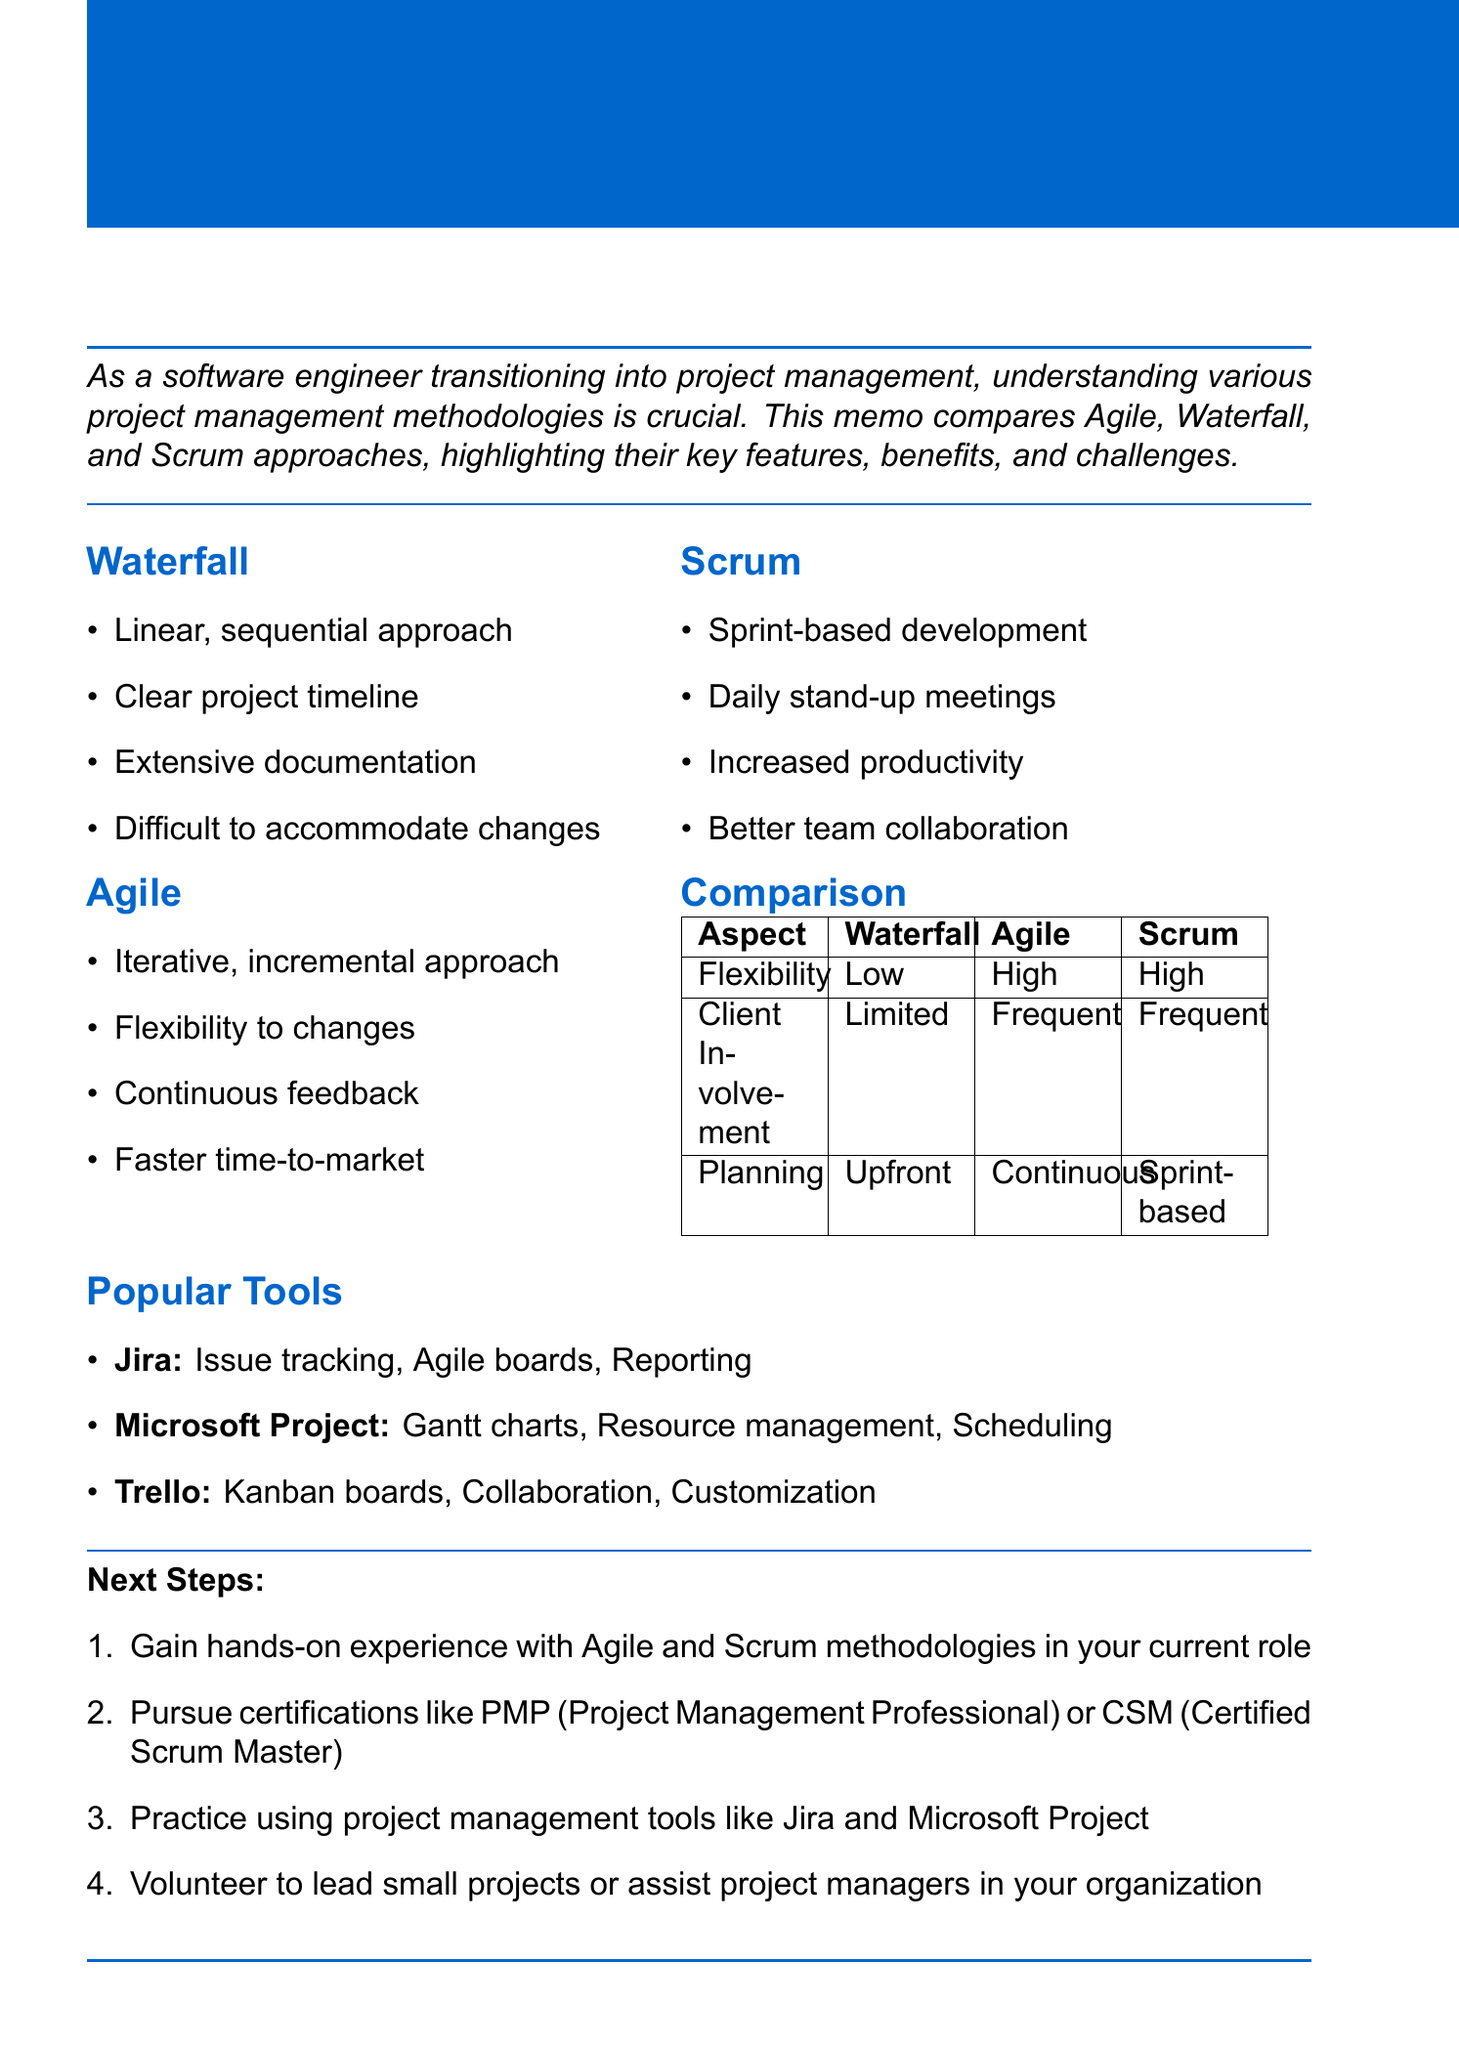What is the title of the memo? The title is provided at the beginning of the document, summarizing the content.
Answer: Project Management Methodologies Comparison: Agile vs. Waterfall vs. Scrum What methodology is described as "a linear, sequential approach"? This description is located in the section discussing different methodologies.
Answer: Waterfall Which methodology is characterized by "sprint-based development"? This characteristic is mentioned in the section focused on Scrum.
Answer: Scrum What are the two methodologies that allow for frequent client involvement? This information is retrieved from the comparison aspects related to client involvement.
Answer: Agile, Scrum What is one major challenge associated with Waterfall? The challenges are listed specifically under the Waterfall methodology.
Answer: Difficult to accommodate changes Which tool is popular for Agile and Scrum project management? The memo identifies specific tools suitable for different methodologies.
Answer: Jira What is the benefit of Agile mentioned in the document? The benefits for each methodology are outlined in their respective sections.
Answer: Flexibility to changes What is the next step suggested after gaining hands-on experience? The next steps are listed for transitioning into project management effectively.
Answer: Pursue certifications like PMP (Project Management Professional) or CSM (Certified Scrum Master) 